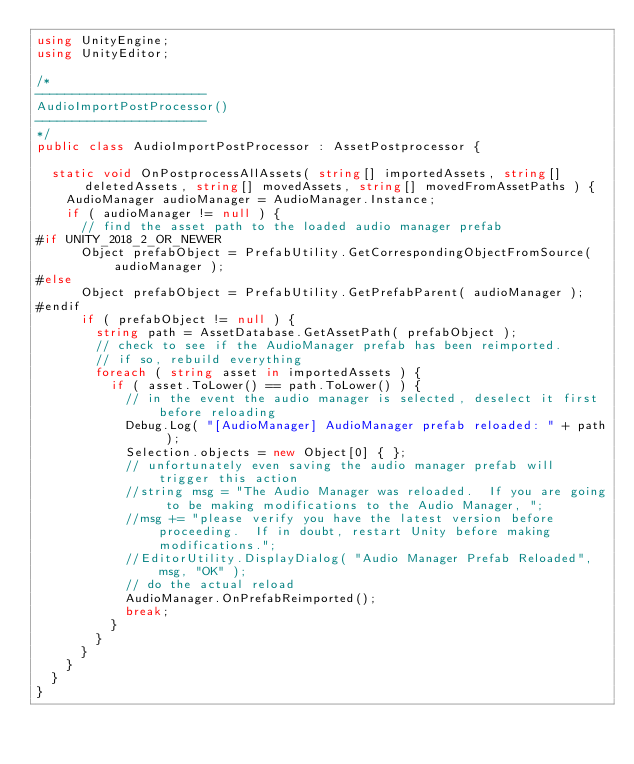Convert code to text. <code><loc_0><loc_0><loc_500><loc_500><_C#_>using UnityEngine;
using UnityEditor;

/*
-----------------------
AudioImportPostProcessor()
-----------------------
*/
public class AudioImportPostProcessor : AssetPostprocessor {

	static void OnPostprocessAllAssets( string[] importedAssets, string[] deletedAssets, string[] movedAssets, string[] movedFromAssetPaths ) {
		AudioManager audioManager = AudioManager.Instance;
		if ( audioManager != null ) {
			// find the asset path to the loaded audio manager prefab
#if UNITY_2018_2_OR_NEWER
			Object prefabObject = PrefabUtility.GetCorrespondingObjectFromSource( audioManager );
#else
			Object prefabObject = PrefabUtility.GetPrefabParent( audioManager );
#endif
			if ( prefabObject != null ) {
				string path = AssetDatabase.GetAssetPath( prefabObject );
				// check to see if the AudioManager prefab has been reimported.
				// if so, rebuild everything
				foreach ( string asset in importedAssets ) {
					if ( asset.ToLower() == path.ToLower() ) {
						// in the event the audio manager is selected, deselect it first before reloading
						Debug.Log( "[AudioManager] AudioManager prefab reloaded: " + path );
						Selection.objects = new Object[0] { };
						// unfortunately even saving the audio manager prefab will trigger this action
						//string msg = "The Audio Manager was reloaded.  If you are going to be making modifications to the Audio Manager, ";
						//msg += "please verify you have the latest version before proceeding.  If in doubt, restart Unity before making modifications.";
						//EditorUtility.DisplayDialog( "Audio Manager Prefab Reloaded", msg, "OK" );
						// do the actual reload
						AudioManager.OnPrefabReimported();
						break;
					}
				}
			}
		}
	}
}
</code> 